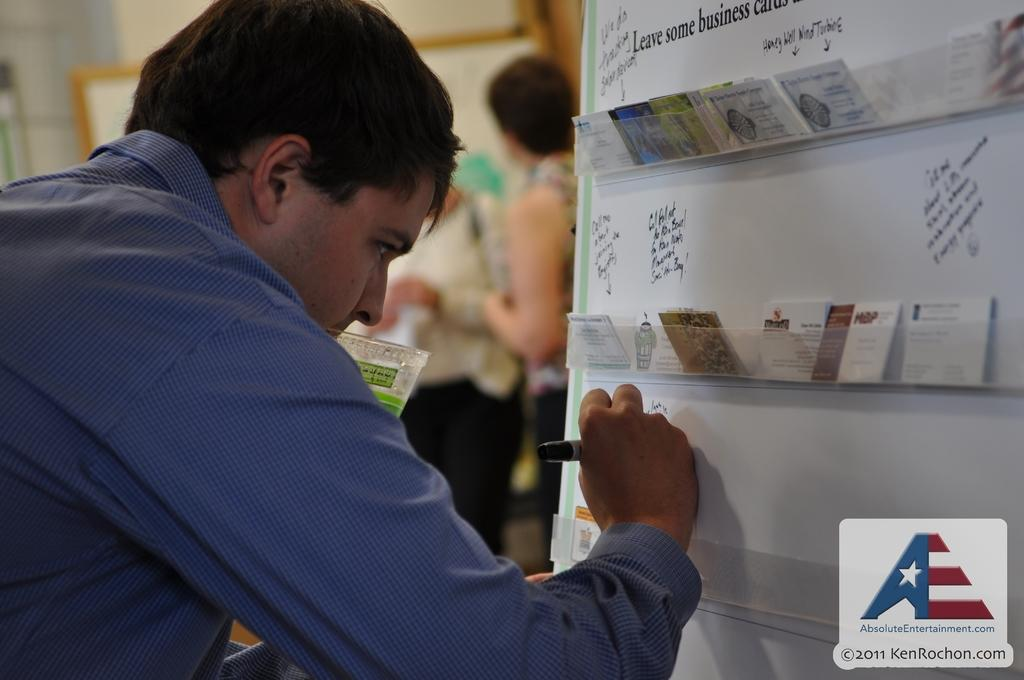Provide a one-sentence caption for the provided image. A man writing on a wall with the picture coming from Absoluteentertainment.com. 